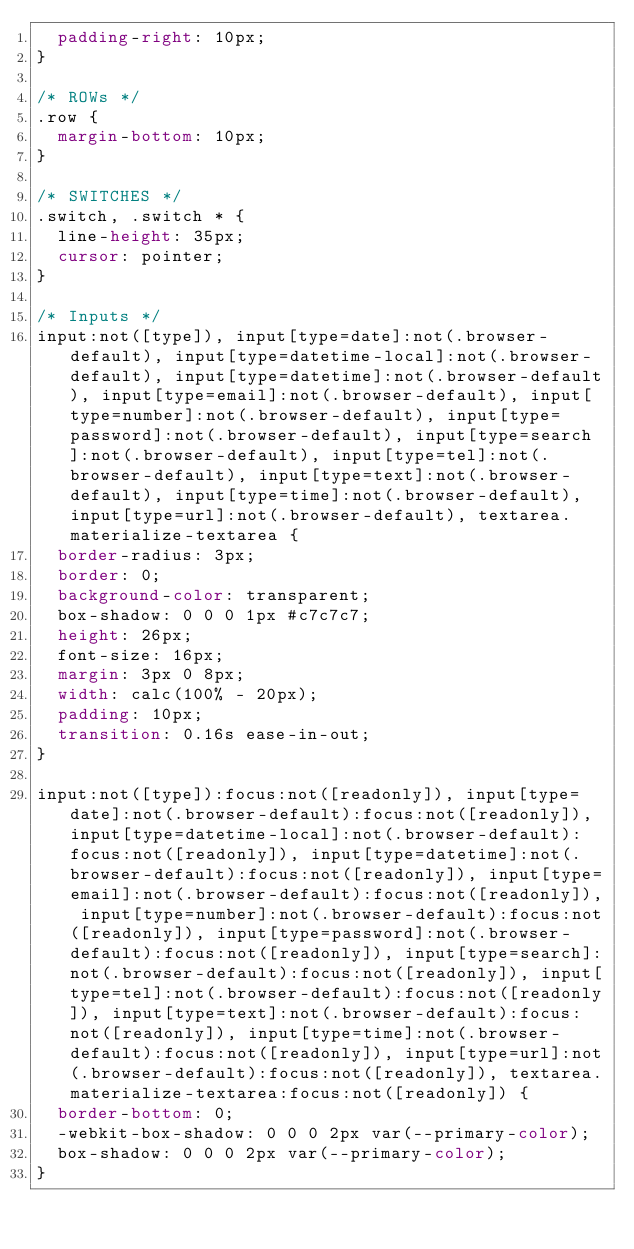Convert code to text. <code><loc_0><loc_0><loc_500><loc_500><_CSS_>  padding-right: 10px;
}

/* ROWs */
.row {
  margin-bottom: 10px;
}

/* SWITCHES */
.switch, .switch * {
  line-height: 35px;
  cursor: pointer;
}

/* Inputs */
input:not([type]), input[type=date]:not(.browser-default), input[type=datetime-local]:not(.browser-default), input[type=datetime]:not(.browser-default), input[type=email]:not(.browser-default), input[type=number]:not(.browser-default), input[type=password]:not(.browser-default), input[type=search]:not(.browser-default), input[type=tel]:not(.browser-default), input[type=text]:not(.browser-default), input[type=time]:not(.browser-default), input[type=url]:not(.browser-default), textarea.materialize-textarea {
  border-radius: 3px;
  border: 0;
  background-color: transparent;
  box-shadow: 0 0 0 1px #c7c7c7;
  height: 26px;
  font-size: 16px;
  margin: 3px 0 8px;
  width: calc(100% - 20px);
  padding: 10px;
  transition: 0.16s ease-in-out;
}

input:not([type]):focus:not([readonly]), input[type=date]:not(.browser-default):focus:not([readonly]), input[type=datetime-local]:not(.browser-default):focus:not([readonly]), input[type=datetime]:not(.browser-default):focus:not([readonly]), input[type=email]:not(.browser-default):focus:not([readonly]), input[type=number]:not(.browser-default):focus:not([readonly]), input[type=password]:not(.browser-default):focus:not([readonly]), input[type=search]:not(.browser-default):focus:not([readonly]), input[type=tel]:not(.browser-default):focus:not([readonly]), input[type=text]:not(.browser-default):focus:not([readonly]), input[type=time]:not(.browser-default):focus:not([readonly]), input[type=url]:not(.browser-default):focus:not([readonly]), textarea.materialize-textarea:focus:not([readonly]) {
  border-bottom: 0;
  -webkit-box-shadow: 0 0 0 2px var(--primary-color);
  box-shadow: 0 0 0 2px var(--primary-color);
}
</code> 